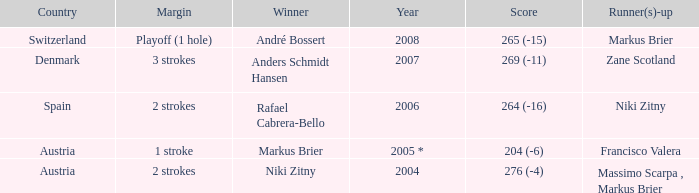Who was the runner-up when the margin was 1 stroke? Francisco Valera. 